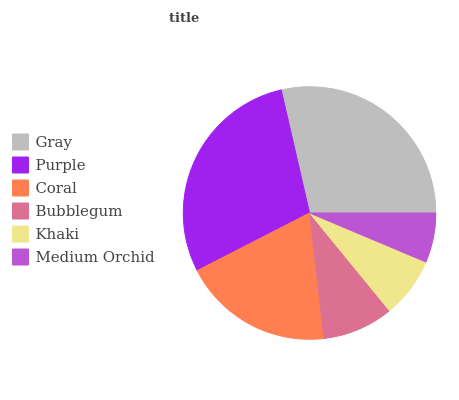Is Medium Orchid the minimum?
Answer yes or no. Yes. Is Purple the maximum?
Answer yes or no. Yes. Is Coral the minimum?
Answer yes or no. No. Is Coral the maximum?
Answer yes or no. No. Is Purple greater than Coral?
Answer yes or no. Yes. Is Coral less than Purple?
Answer yes or no. Yes. Is Coral greater than Purple?
Answer yes or no. No. Is Purple less than Coral?
Answer yes or no. No. Is Coral the high median?
Answer yes or no. Yes. Is Bubblegum the low median?
Answer yes or no. Yes. Is Medium Orchid the high median?
Answer yes or no. No. Is Medium Orchid the low median?
Answer yes or no. No. 